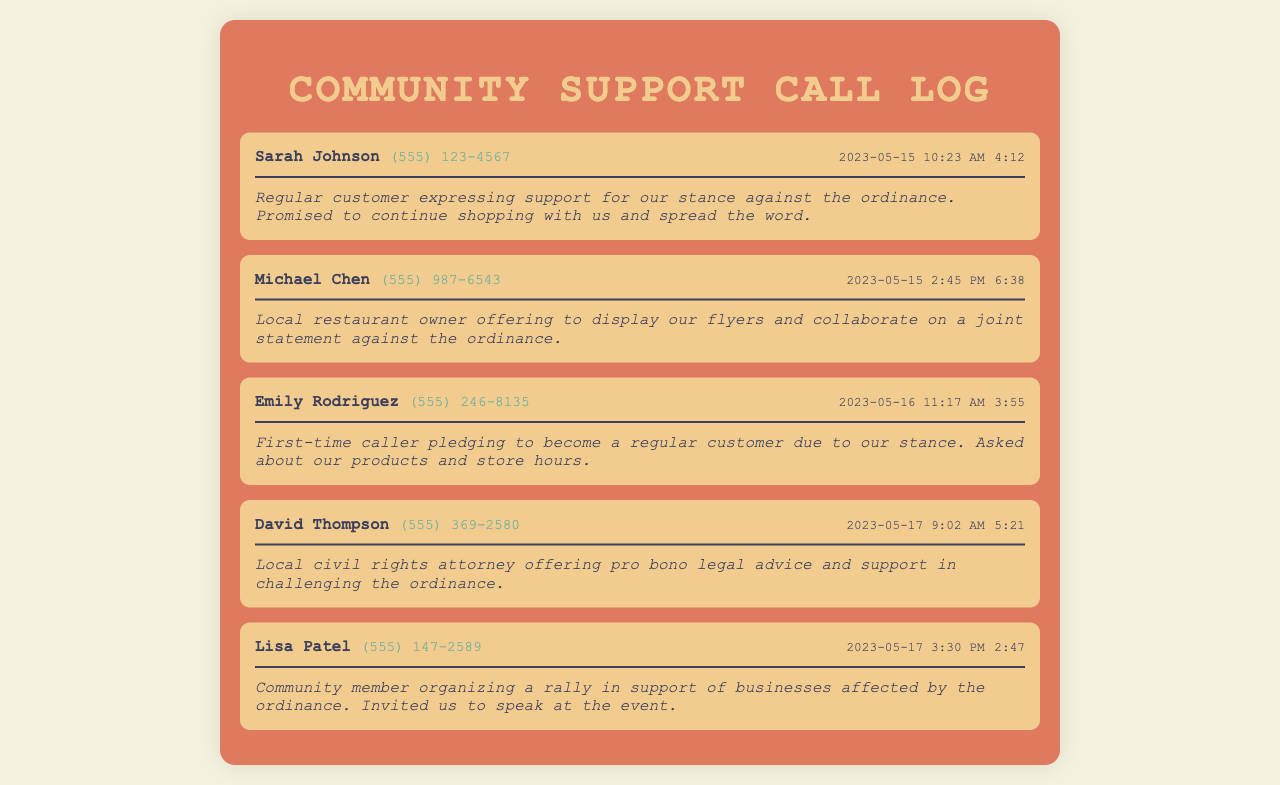What is the name of the first caller? The name of the first caller can be found in the document under the caller header of the first record.
Answer: Sarah Johnson What is the date of Michael Chen's call? The date of Michael Chen's call is mentioned along with the time in his record, which is in the header section.
Answer: 2023-05-15 How long did Emily Rodriguez's call last? Emily Rodriguez's call duration can be found in her call record, specifically noted under the duration section.
Answer: 3:55 Who offered pro bono legal advice? The caller offering pro bono legal advice is identified in the record, listed under the caller name in the header.
Answer: David Thompson What event did Lisa Patel invite the business to? The event Lisa Patel invited the business to is recorded in her response, mentioning the context of community support.
Answer: Rally Who is a regular customer expressing support? The type of information in Sarah Johnson's record identifies her affinity to the business and her customer status.
Answer: Sarah Johnson What was the time of David Thompson's call? The time of David Thompson's call can be found in the header section of his record.
Answer: 9:02 AM How many calls are recorded in total? The total number of calls can be counted by reviewing the number of records present in the document.
Answer: 5 